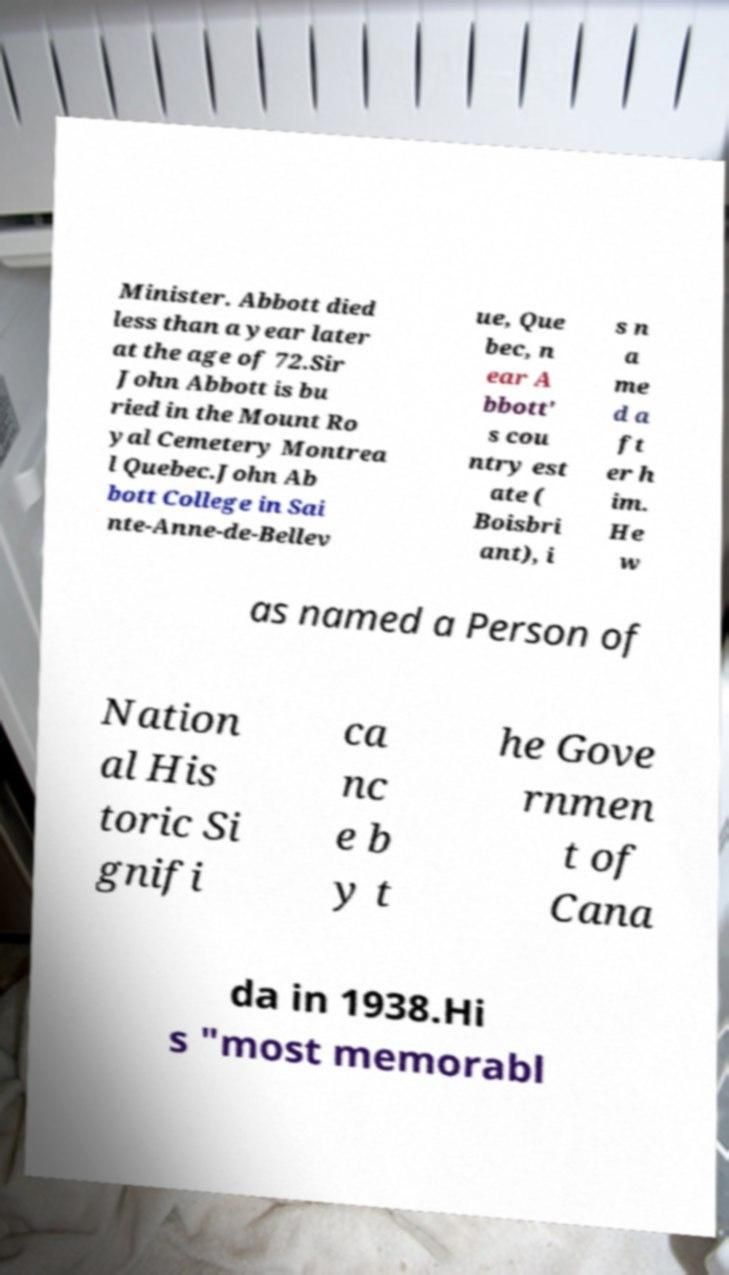Can you read and provide the text displayed in the image?This photo seems to have some interesting text. Can you extract and type it out for me? Minister. Abbott died less than a year later at the age of 72.Sir John Abbott is bu ried in the Mount Ro yal Cemetery Montrea l Quebec.John Ab bott College in Sai nte-Anne-de-Bellev ue, Que bec, n ear A bbott' s cou ntry est ate ( Boisbri ant), i s n a me d a ft er h im. He w as named a Person of Nation al His toric Si gnifi ca nc e b y t he Gove rnmen t of Cana da in 1938.Hi s "most memorabl 